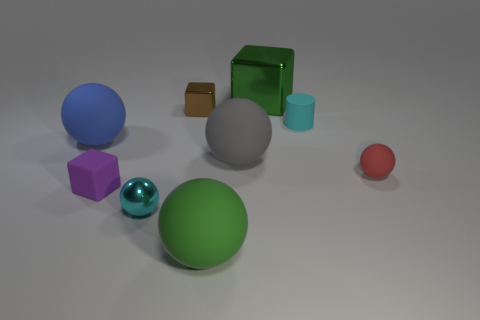What number of other tiny cubes have the same color as the rubber cube?
Your answer should be compact. 0. How big is the purple block on the left side of the big green rubber thing in front of the tiny cyan cylinder?
Offer a very short reply. Small. How many things are tiny cyan things in front of the tiny purple matte object or big balls?
Make the answer very short. 4. Is there a rubber ball of the same size as the blue matte thing?
Ensure brevity in your answer.  Yes. Are there any small cylinders that are in front of the tiny rubber thing that is to the left of the cyan shiny object?
Provide a succinct answer. No. How many cylinders are big metallic things or big gray rubber things?
Your response must be concise. 0. Are there any big green metal objects of the same shape as the blue object?
Make the answer very short. No. The small purple matte thing has what shape?
Offer a terse response. Cube. How many things are tiny cyan rubber things or tiny gray balls?
Offer a terse response. 1. Does the metal thing behind the brown shiny cube have the same size as the object that is to the right of the cylinder?
Make the answer very short. No. 